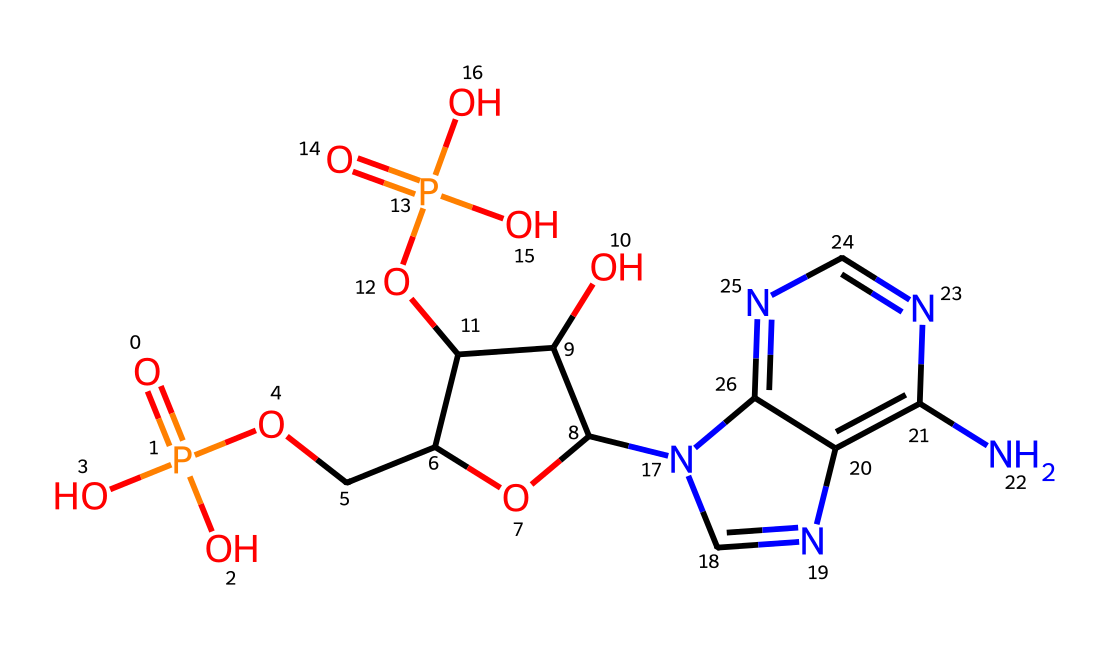How many phosphate groups are present in the chemical structure? The SMILES representation indicates the presence of two phosphate groups, indicated by the "P" atoms surrounded by oxygen (O) atoms in the formula.
Answer: two What type of molecule is formed by this structure? The nucleotide structure, which consists of a sugar, nitrogenous base, and phosphate group, is inferred from the constituent elements and arrangement in the chemical shown.
Answer: nucleotide What is the base structure of this nucleotide? The chemical structure contains a "C" connected to a "n" and shows a cyclic part, indicating that a ribose sugar and a nitrogenous base are included.
Answer: ribose How many nitrogen atoms are in the structure? The analysis of the SMILES shows three nitrogen ("n") atoms are present in the sequence, which is counted directly from the string representation.
Answer: three What is the role of the phosphate group in DNA nucleotides? The phosphate group connects nucleotides together, creating the backbone of DNA, as indicated by its presence and connections in the structure.
Answer: backbone What functional groups are present along with the phosphate groups? The presence of hydroxyl groups ("O") connected to the carbon atoms near the phosphate indicates functional groups that are vital for the structure.
Answer: hydroxyl groups 